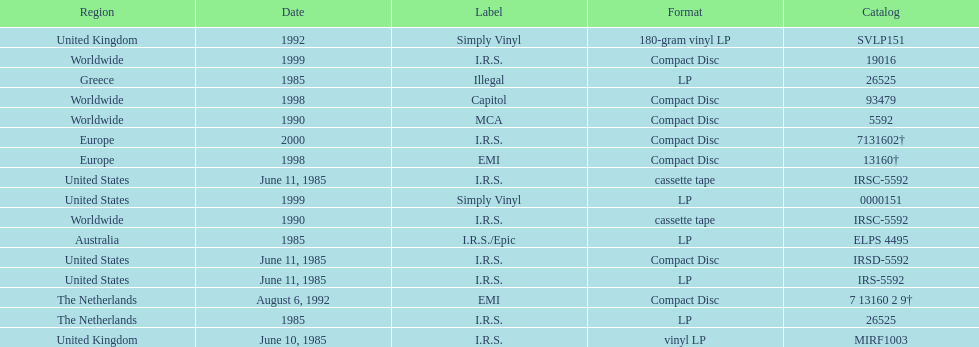What was the date of the first vinyl lp release? June 10, 1985. 